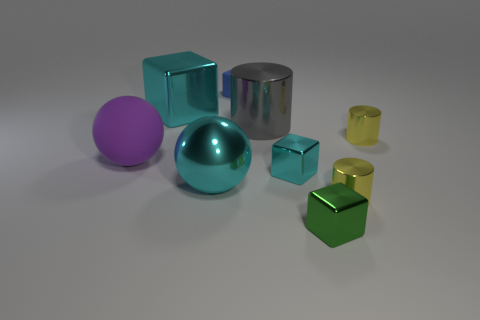What size is the cube that is both in front of the purple matte object and behind the tiny green cube?
Provide a short and direct response. Small. What color is the small cylinder that is behind the big object in front of the large matte ball?
Provide a succinct answer. Yellow. What number of blue objects are matte objects or big metal cubes?
Offer a terse response. 1. There is a tiny cube that is both behind the big cyan sphere and on the right side of the matte block; what color is it?
Your response must be concise. Cyan. What number of small things are yellow objects or metallic things?
Your answer should be very brief. 4. There is a cyan metallic object that is the same shape as the large purple matte thing; what is its size?
Your answer should be very brief. Large. The big gray object has what shape?
Provide a short and direct response. Cylinder. Do the big purple object and the big cyan cube that is behind the gray metal cylinder have the same material?
Keep it short and to the point. No. What number of metallic objects are small cyan blocks or red cubes?
Your response must be concise. 1. There is a yellow shiny thing that is behind the large purple sphere; what is its size?
Your response must be concise. Small. 